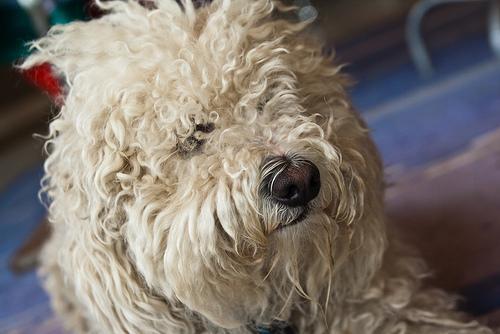How many dogs are in the picture?
Give a very brief answer. 1. 